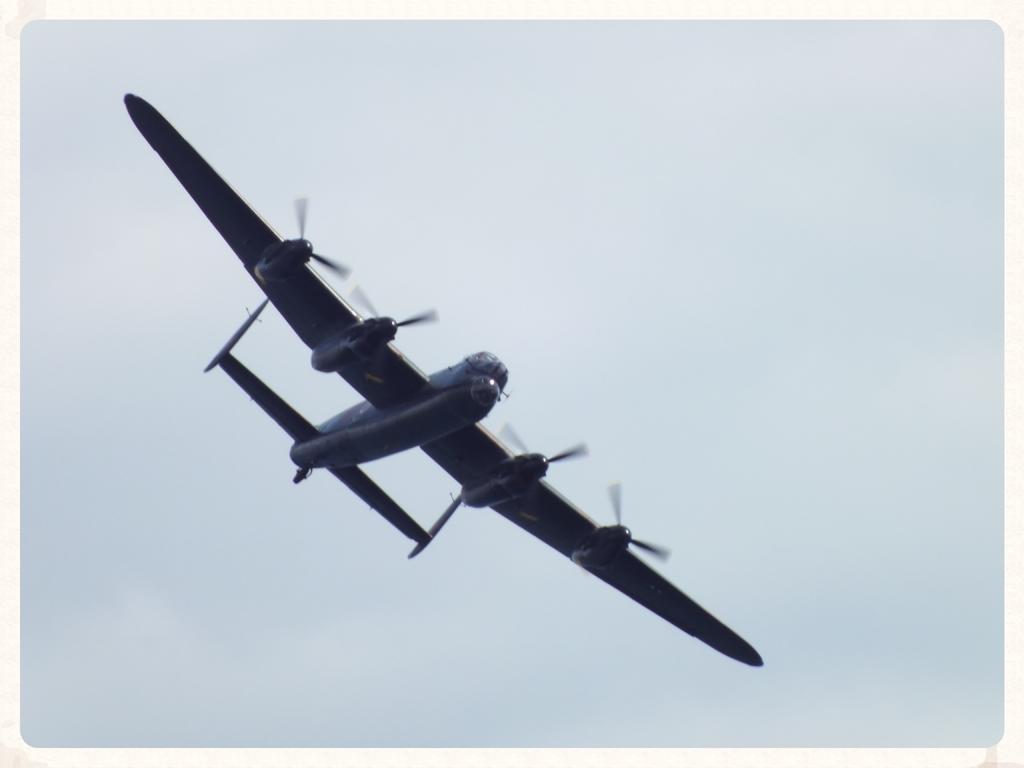Please provide a concise description of this image. In this picture there is an aircraft flying. At the top there is sky. This picture is an edited picture. 